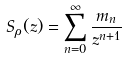Convert formula to latex. <formula><loc_0><loc_0><loc_500><loc_500>S _ { \rho } ( z ) = \sum _ { n = 0 } ^ { \infty } \frac { m _ { n } } { z ^ { n + 1 } }</formula> 